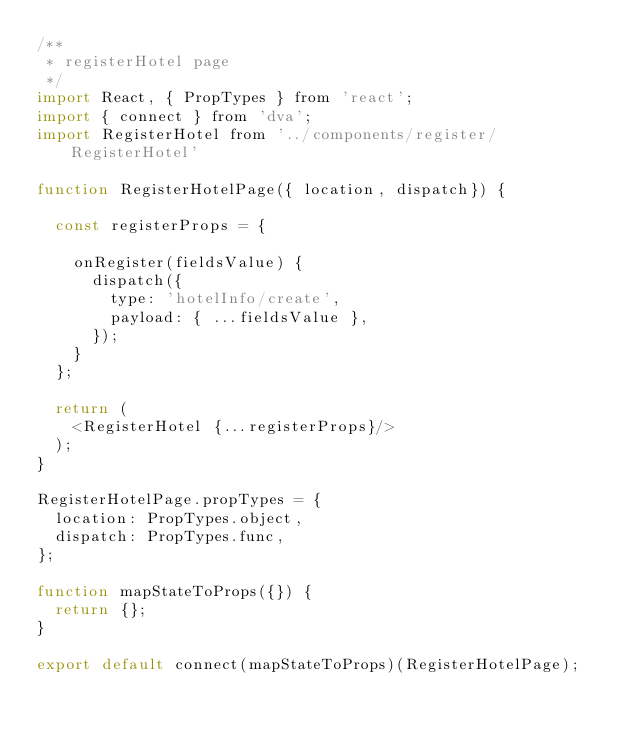Convert code to text. <code><loc_0><loc_0><loc_500><loc_500><_JavaScript_>/**
 * registerHotel page
 */
import React, { PropTypes } from 'react';
import { connect } from 'dva';
import RegisterHotel from '../components/register/RegisterHotel'

function RegisterHotelPage({ location, dispatch}) {

  const registerProps = {

    onRegister(fieldsValue) {
      dispatch({
        type: 'hotelInfo/create',
        payload: { ...fieldsValue },
      });
    }
  };

  return (
    <RegisterHotel {...registerProps}/>
  );
}

RegisterHotelPage.propTypes = {
  location: PropTypes.object,
  dispatch: PropTypes.func,
};

function mapStateToProps({}) {
  return {};
}

export default connect(mapStateToProps)(RegisterHotelPage);

</code> 